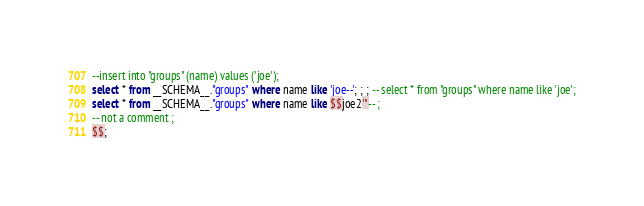Convert code to text. <code><loc_0><loc_0><loc_500><loc_500><_SQL_>--insert into "groups" (name) values ('joe');
select * from __SCHEMA__."groups" where name like 'joe--'; ; ; -- select * from "groups" where name like 'joe';
select * from __SCHEMA__."groups" where name like $$joe2'"-- ;
-- not a comment ;
$$;
</code> 